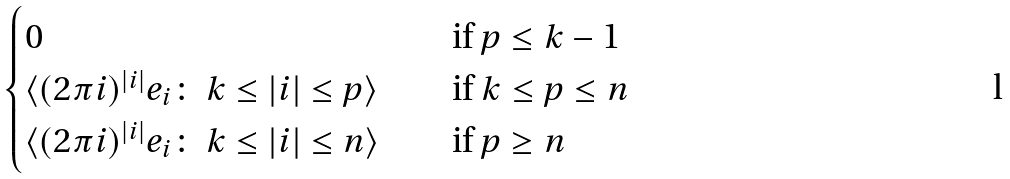<formula> <loc_0><loc_0><loc_500><loc_500>\begin{cases} 0 & \text {if } p \leq k - 1 \\ \langle ( 2 \pi i ) ^ { | i | } e _ { i } \colon \ k \leq | i | \leq p \rangle \quad & \text {if } k \leq p \leq n \\ \langle ( 2 \pi i ) ^ { | i | } e _ { i } \colon \ k \leq | i | \leq n \rangle & \text {if } p \geq n \end{cases}</formula> 